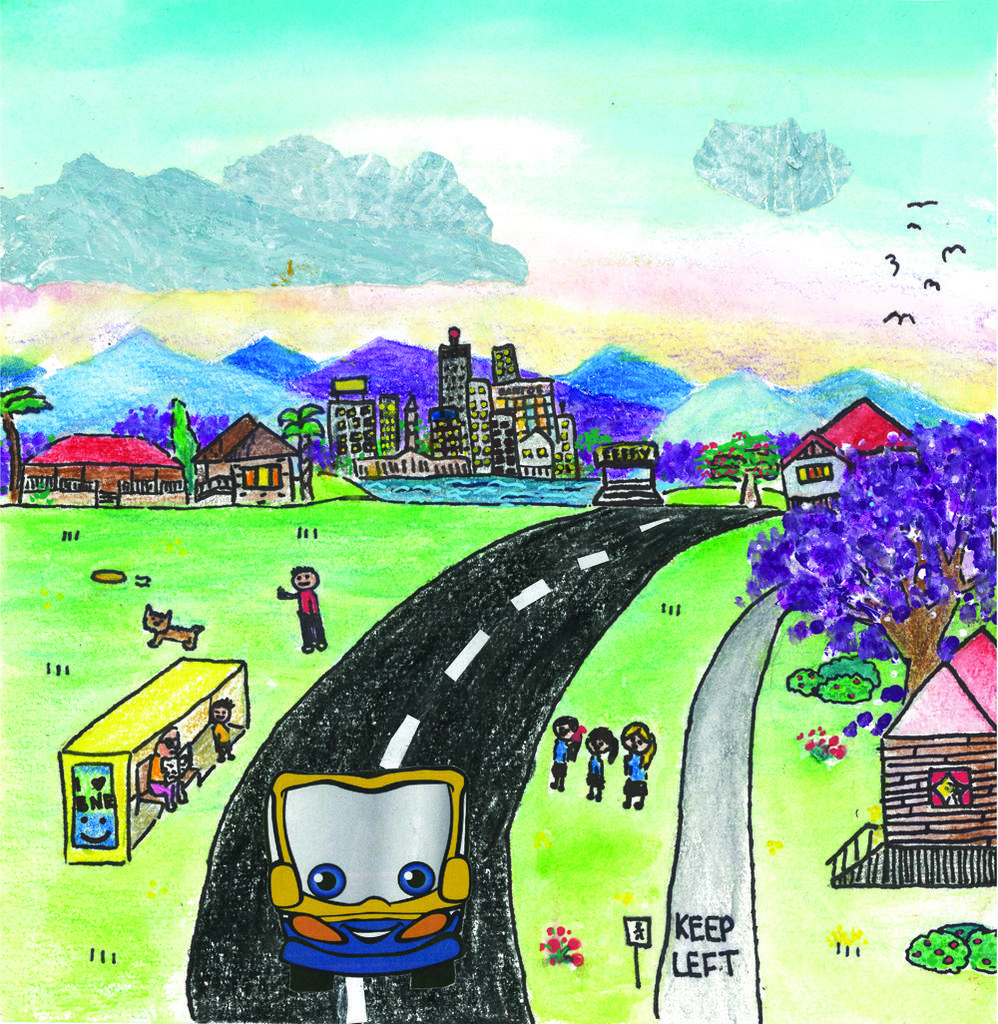What type of artwork is depicted in the image? The image is a sketch painting. What is one of the main features of the landscape in the image? There is a road in the image. What vehicle can be seen in the image? There is a truck in the image. Are there any living beings present in the image? Yes, there are persons present in the image. What natural element is present in the image? There is a tree in the image. What type of structure can be seen in the image? There is a building in the image. What geographical feature is visible in the image? There is a mountain in the image. What atmospheric elements are present in the image? There are clouds in the image. Are there any animals present in the image? Yes, there are birds in the image. What type of vegetation is present in the image? There is grass in the image. What type of experience does the grass have in the image? The grass does not have any experience in the image, as it is an inanimate object. 